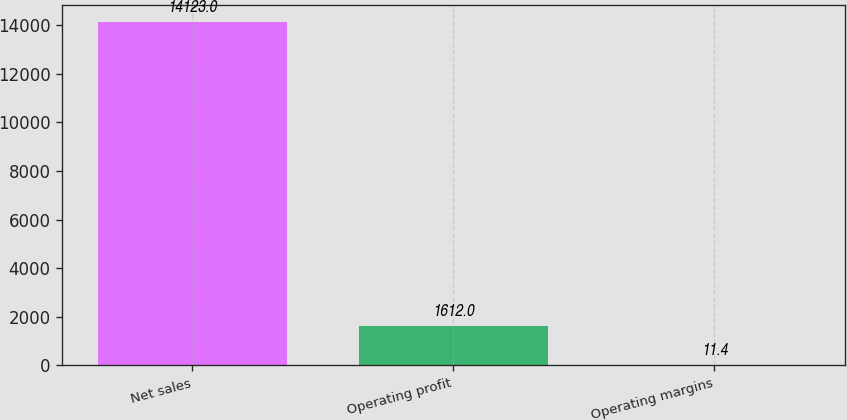Convert chart to OTSL. <chart><loc_0><loc_0><loc_500><loc_500><bar_chart><fcel>Net sales<fcel>Operating profit<fcel>Operating margins<nl><fcel>14123<fcel>1612<fcel>11.4<nl></chart> 